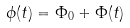Convert formula to latex. <formula><loc_0><loc_0><loc_500><loc_500>\phi ( t ) = \Phi _ { 0 } + \Phi ( t )</formula> 